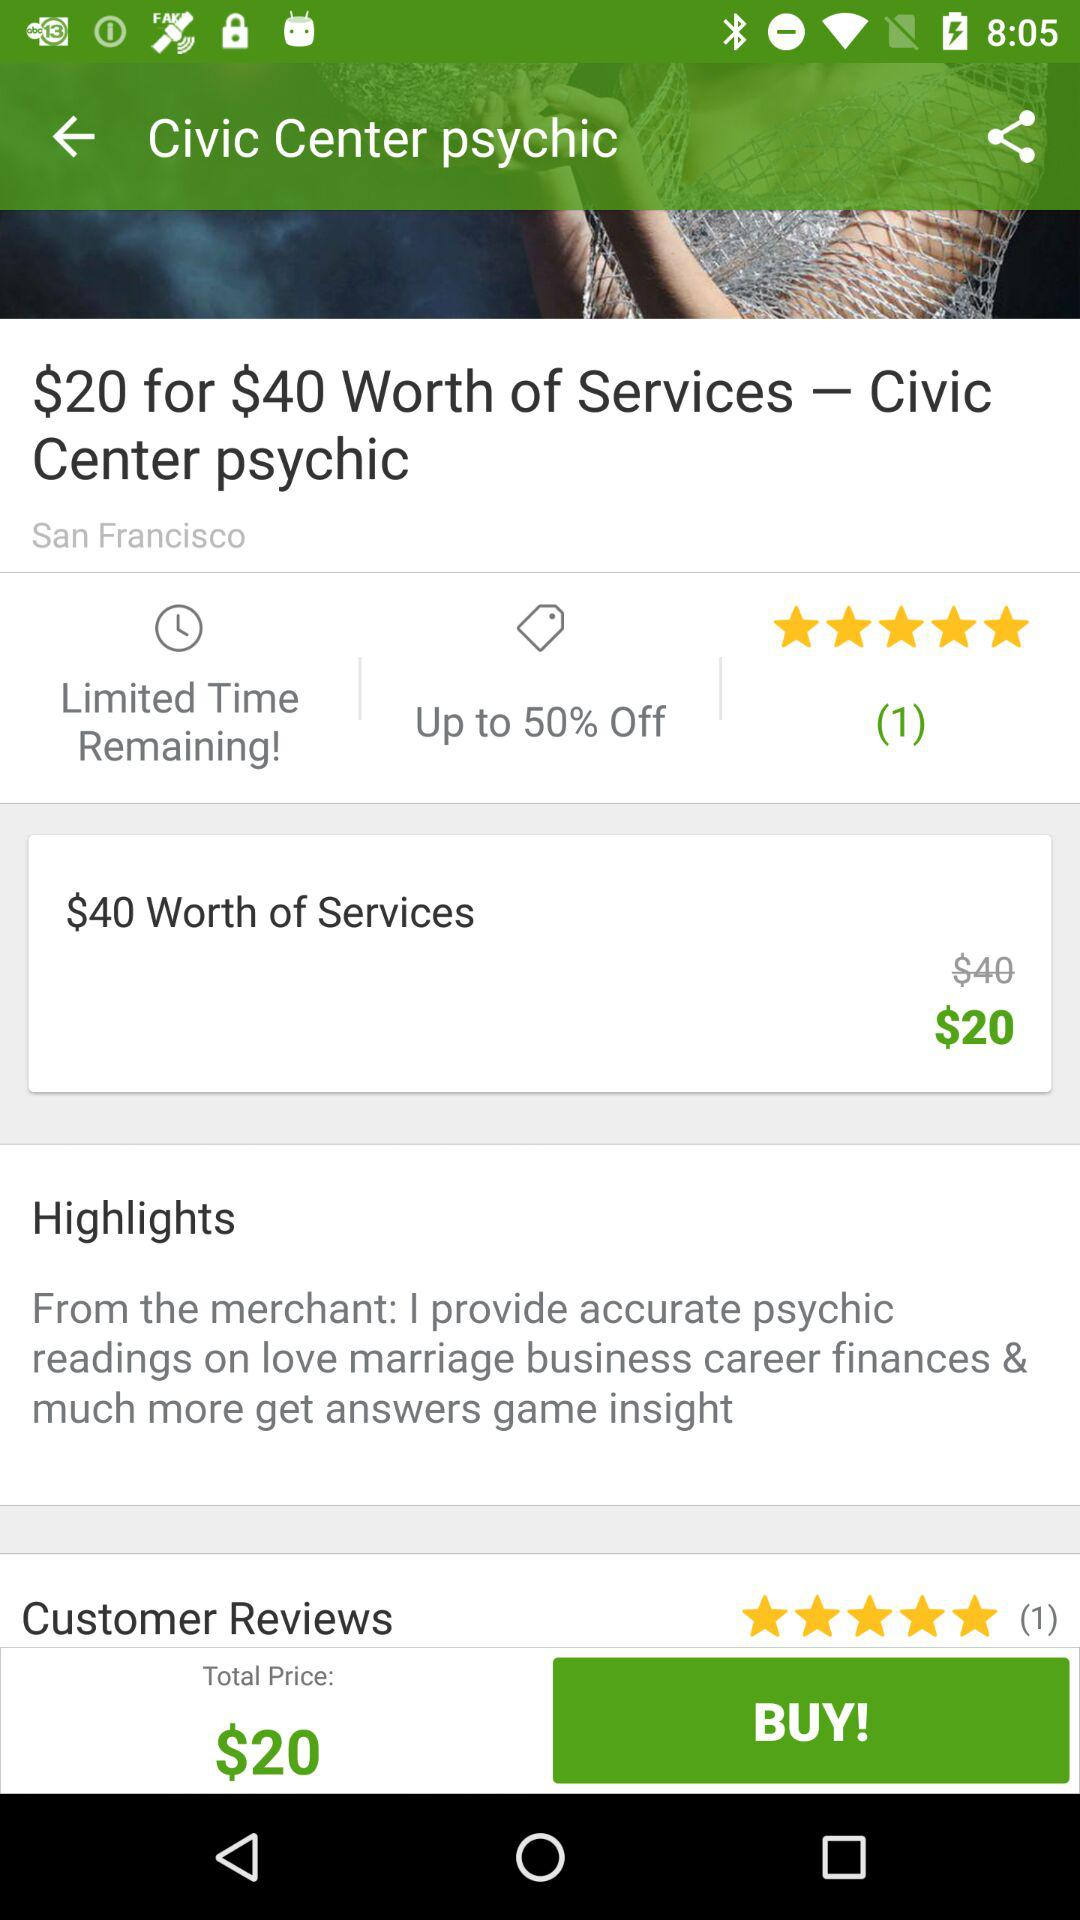How many people have rated the Civic Center psychic? There is 1 person who has rated the Civic Center psychic. 